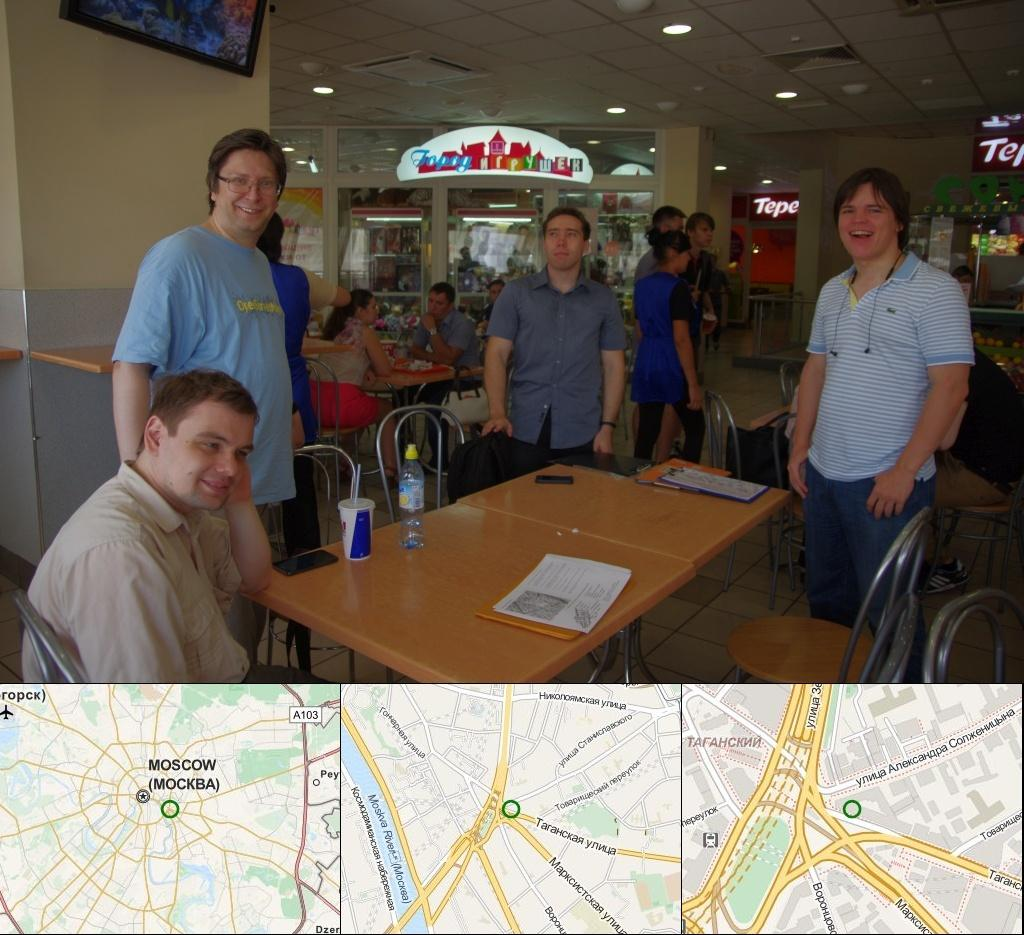What are the people in the image doing? Some people are standing, while others are seated on chairs in the image. What objects can be seen on the table in the image? There is a glass bottle and paper on the table in the image. Where is the photo frame located in the image? The photo frame is on the wall in the image. What type of war is depicted in the photo frame on the wall? There is no war depicted in the photo frame on the wall; it is a photo frame containing a photograph or artwork. What degree of education is required to be seated in the chairs in the image? There is no mention of education or degrees in the image; people are simply seated on chairs. 